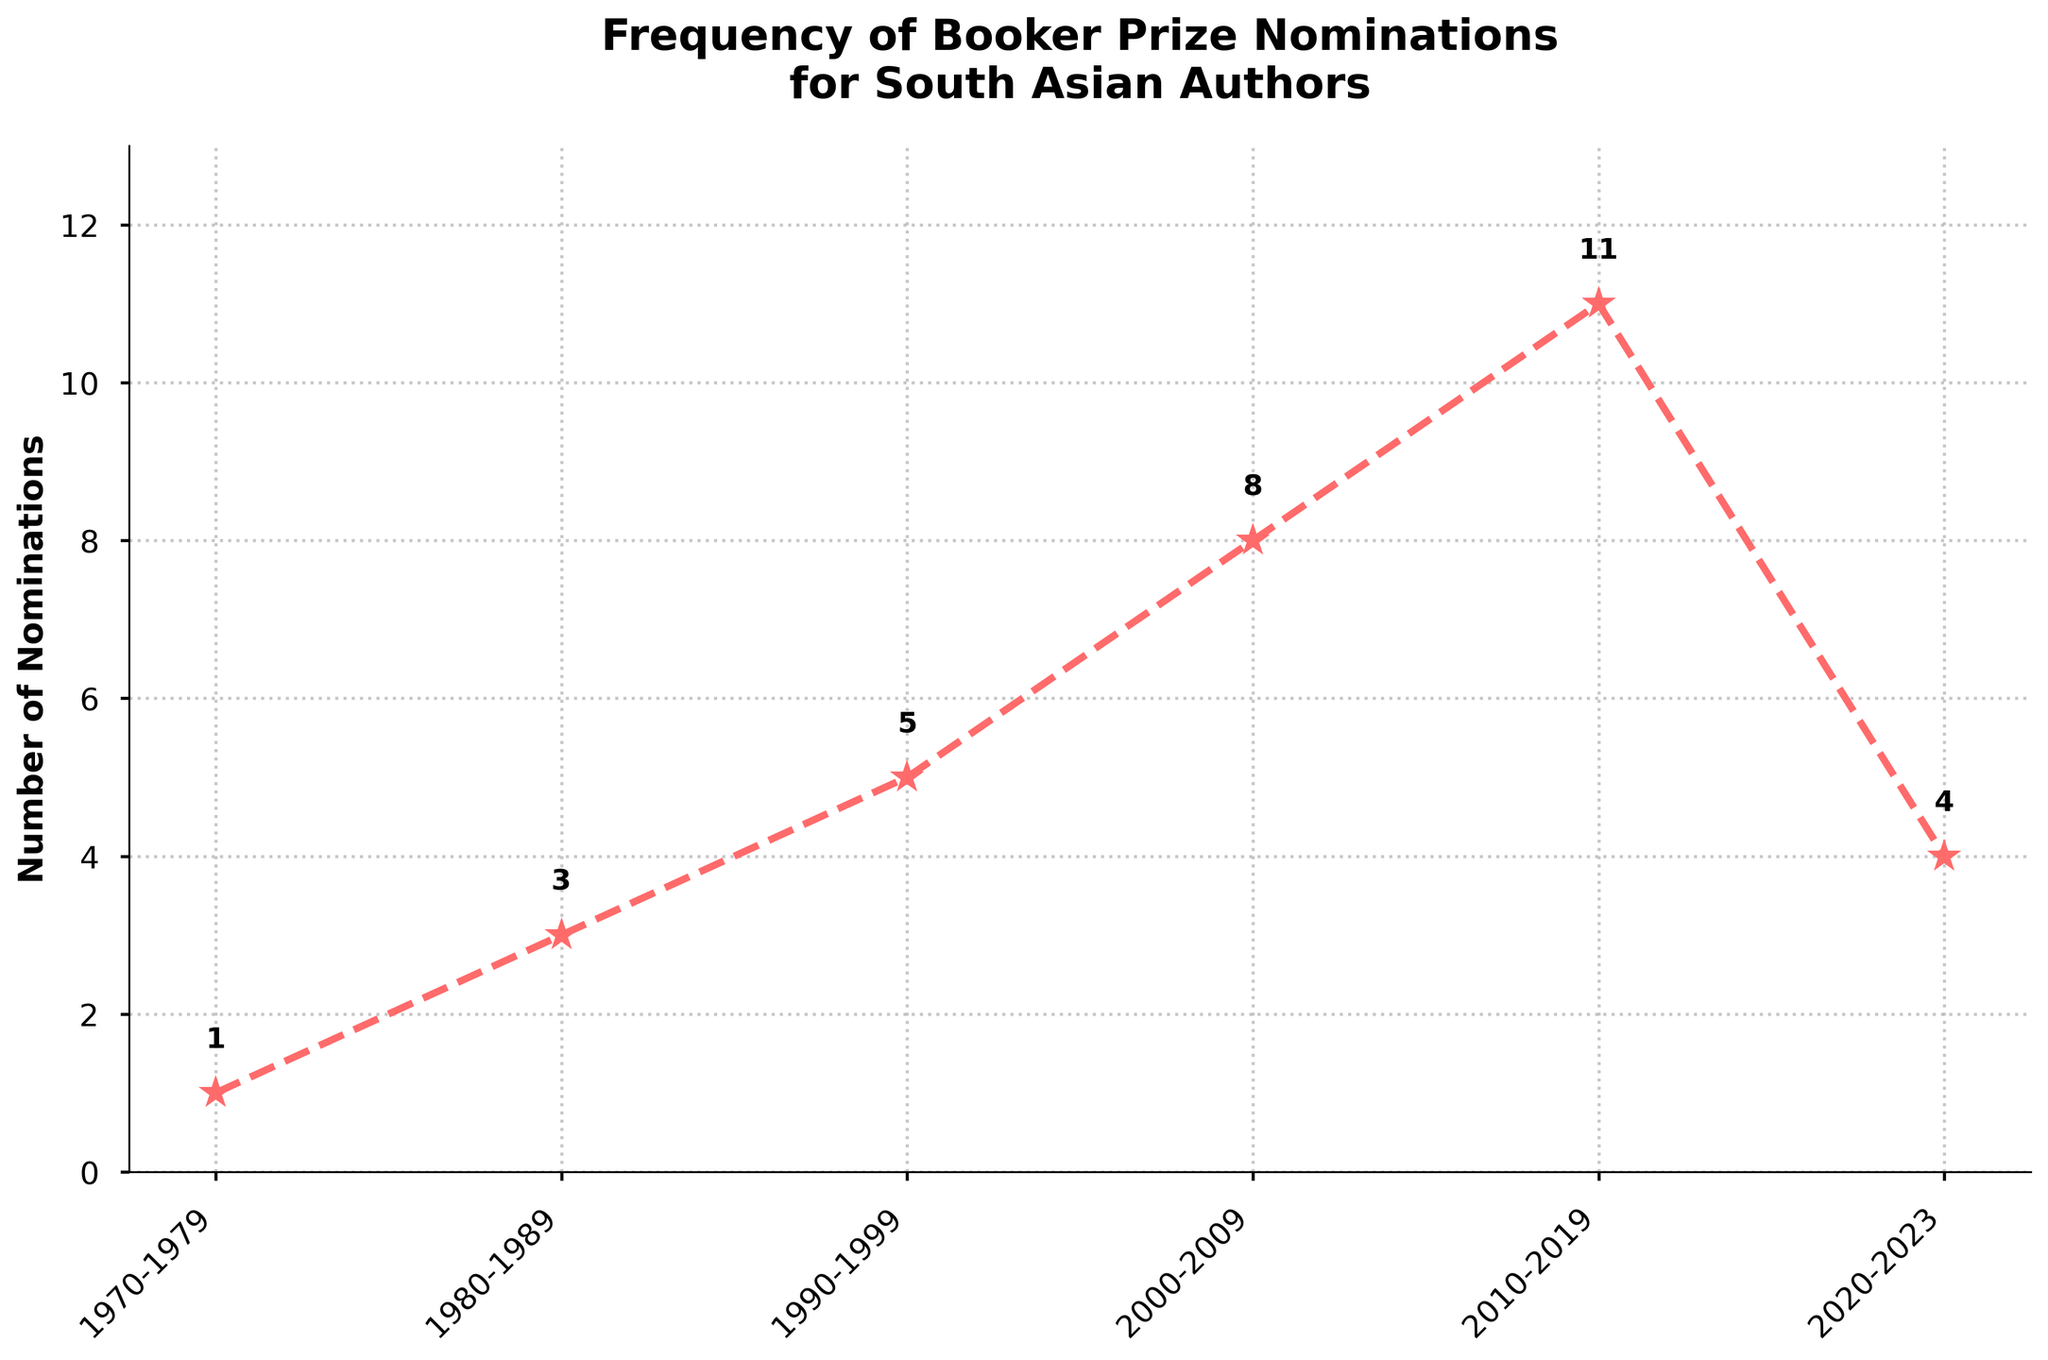Which decade saw the highest number of Booker Prize nominations for South Asian authors? The figure shows the number of nominations for each decade. The highest point on the line chart corresponds to the decade 2010-2019 with 11 nominations.
Answer: 2010-2019 How many total nominations were there from 2000 to 2019? Identify the nominations for the decades 2000-2009 and 2010-2019, which are 8 and 11 respectively. Sum them up: 8 + 11 = 19.
Answer: 19 In which decades did the number of nominations increase by more than 2 compared to the previous decade? Compare the increase in nominations between each consecutive decade: from 1970-1979 (1) to 1980-1989 (3) is an increase of 2; from 1980-1989 (3) to 1990-1999 (5) is an increase of 2; from 1990-1999 (5) to 2000-2009 (8) is an increase of 3; from 2000-2009 (8) to 2010-2019 (11) is an increase of 3.
Answer: 1990-1999 to 2000-2009, 2000-2009 to 2010-2019 Between which consecutive decades was the increase in nominations the greatest? Assess the differences in nominations between each consecutive decade: 1980-1989 (3-1 = 2), 1990-1999 (5-3 = 2), 2000-2009 (8-5 = 3), 2010-2019 (11-8 = 3), 2020-2023 (4-11 = -7). The greatest increase of 3 nominations occurred between 1990-1999 to 2000-2009 and 2000-2009 to 2010-2019.
Answer: 1990-1999 to 2000-2009 or 2000-2009 to 2010-2019 What is the difference in the number of nominations between 1980-1989 and 2020-2023? Refer to the chart to find the number of nominations in those decades: 1980-1989 had 3 nominations, and 2020-2023 had 4 nominations. Calculate the difference: 4 - 3 = 1.
Answer: 1 In which decades did the number of nominations increase continuously without a dip? Analyze the trends: from 1970-1979 (1), to 1980-1989 (3), to 1990-1999 (5), to 2000-2009 (8), to 2010-2019 (11), there is a continuous increase. The dip occurs in 2020-2023 (4).
Answer: 1970-2019 How does the increase in nominations from 2000-2009 to 2010-2019 compare to the increase from 2010-2019 to 2020-2023? The number of nominations increased by 3 from 2000-2009 (8) to 2010-2019 (11), but it decreased by 7 from 2010-2019 (11) to 2020-2023 (4).
Answer: Increase by 3 vs Decrease by 7 What was the average number of nominations per decade from 1970 to 2019? Sum the number of nominations from 1970-2019 (1 + 3 + 5 + 8 + 11 = 28) and divide by the number of decades (5): 28/5 = 5.6.
Answer: 5.6 